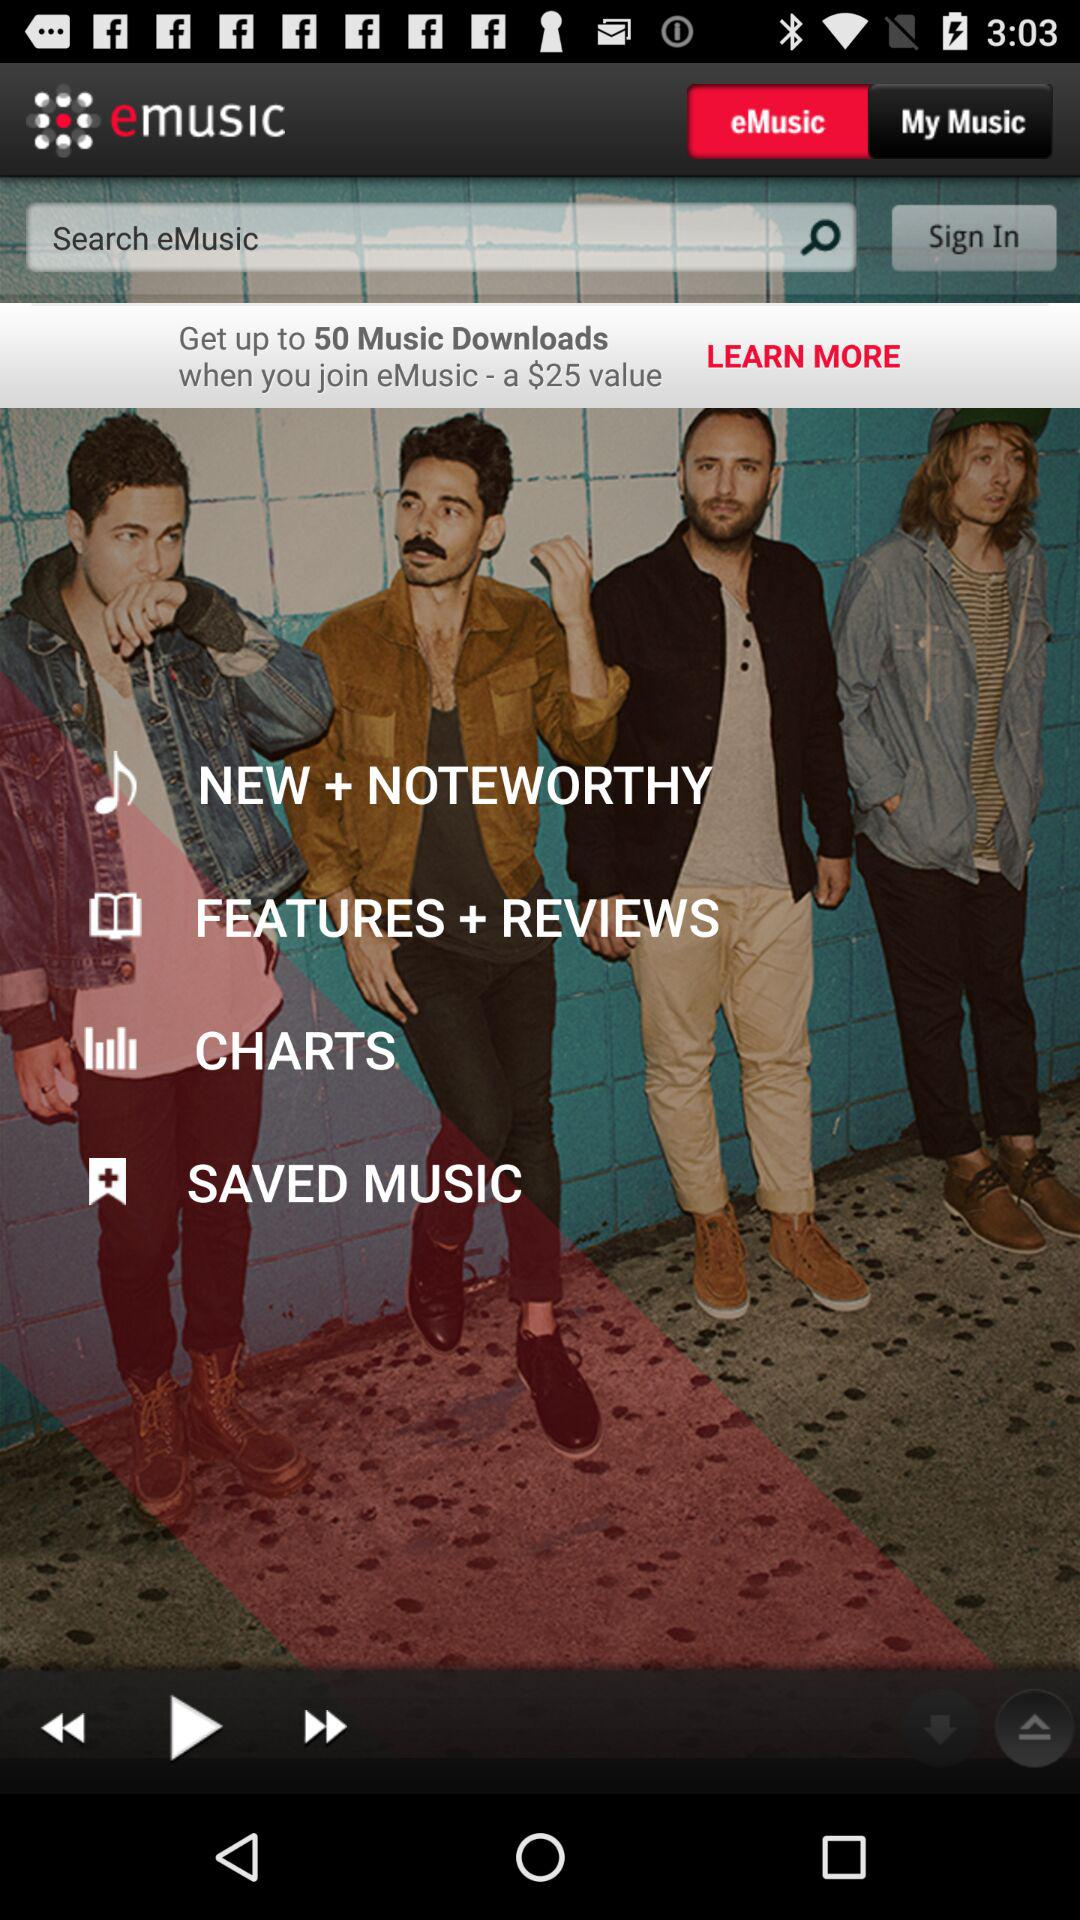How many music downloads do we get when we join "eMusic"? You will get up to 50 music downloads. 